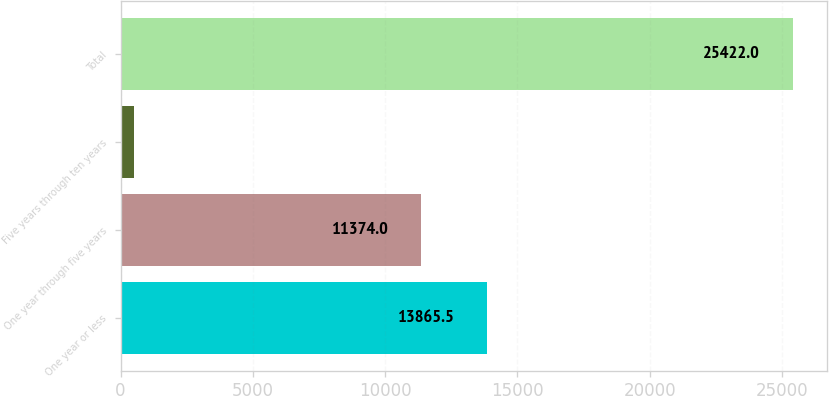Convert chart to OTSL. <chart><loc_0><loc_0><loc_500><loc_500><bar_chart><fcel>One year or less<fcel>One year through five years<fcel>Five years through ten years<fcel>Total<nl><fcel>13865.5<fcel>11374<fcel>507<fcel>25422<nl></chart> 